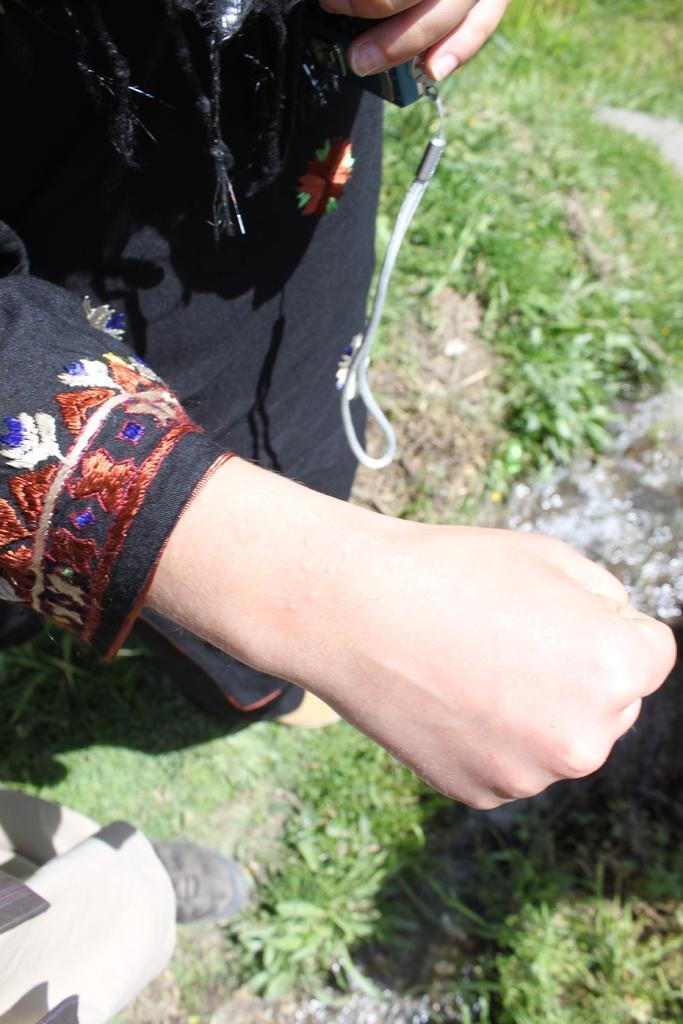Could you give a brief overview of what you see in this image? In this image a lady is showing a hand. She is holding a phone. In the bottom left there is another person. On the ground there are grasses. 